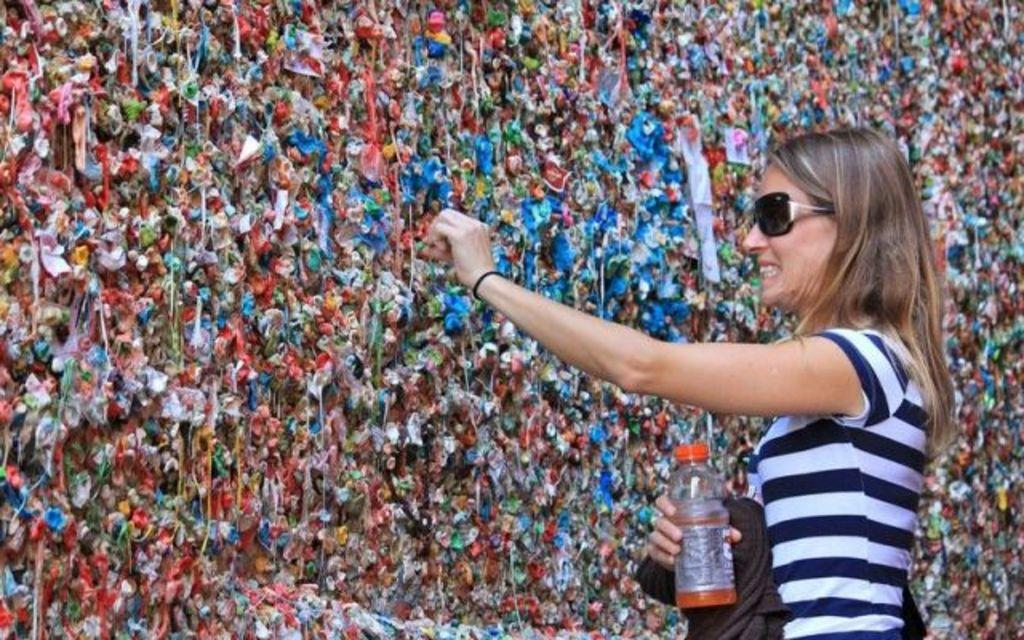Who is the main subject in the image? There is a woman in the image. What is the woman doing in the image? The woman is standing in the image. What object is the woman holding? The woman is holding a water bottle in the image. What can be seen on the wall in front of the woman? There are colorful chewing gums on the wall in front of the woman. How many frogs are sitting on the woman's shoulder in the image? There are no frogs present in the image, so it is not possible to determine how many might be sitting on the woman's shoulder. 